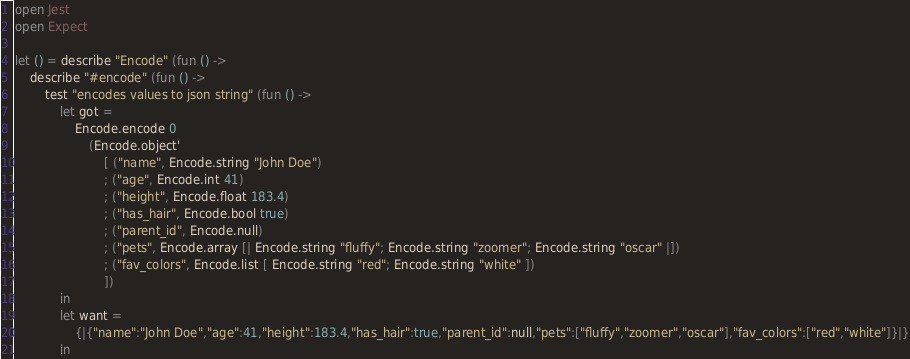<code> <loc_0><loc_0><loc_500><loc_500><_OCaml_>open Jest
open Expect

let () = describe "Encode" (fun () -> 
    describe "#encode" (fun () -> 
        test "encodes values to json string" (fun () -> 
            let got =
                Encode.encode 0
                    (Encode.object' 
                        [ ("name", Encode.string "John Doe")
                        ; ("age", Encode.int 41)
                        ; ("height", Encode.float 183.4)
                        ; ("has_hair", Encode.bool true)
                        ; ("parent_id", Encode.null)
                        ; ("pets", Encode.array [| Encode.string "fluffy"; Encode.string "zoomer"; Encode.string "oscar" |])
                        ; ("fav_colors", Encode.list [ Encode.string "red"; Encode.string "white" ])
                        ])
            in
            let want =
                {|{"name":"John Doe","age":41,"height":183.4,"has_hair":true,"parent_id":null,"pets":["fluffy","zoomer","oscar"],"fav_colors":["red","white"]}|}
            in</code> 